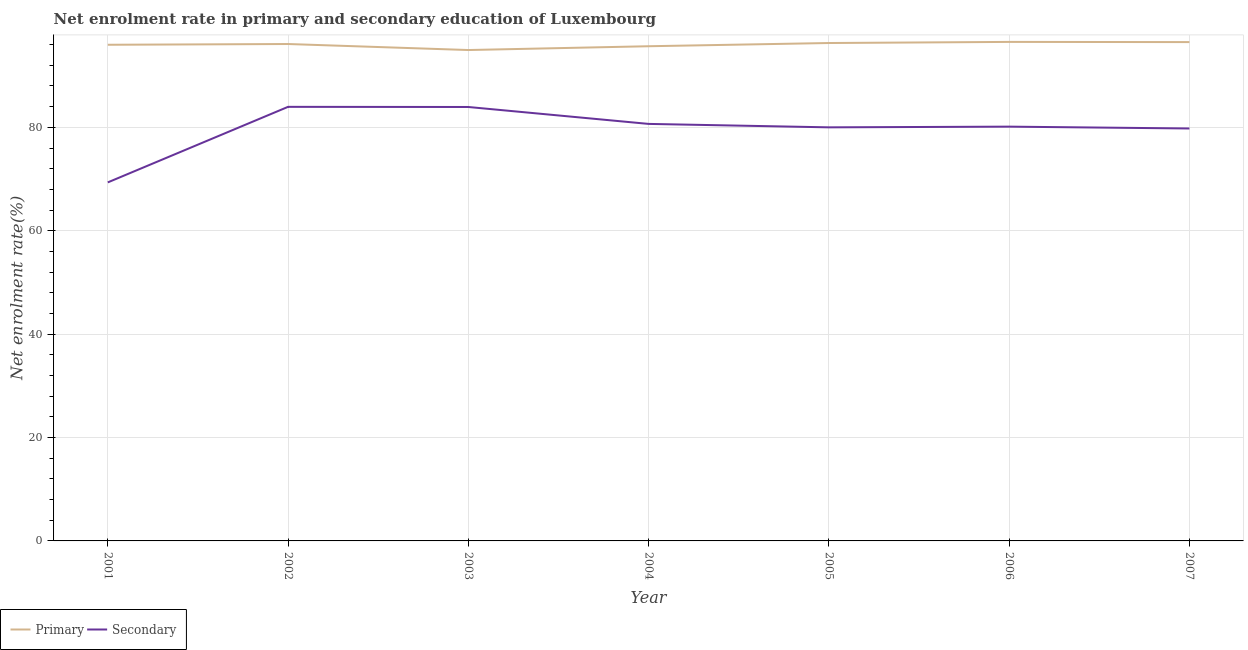Is the number of lines equal to the number of legend labels?
Your response must be concise. Yes. What is the enrollment rate in secondary education in 2006?
Offer a terse response. 80.13. Across all years, what is the maximum enrollment rate in secondary education?
Ensure brevity in your answer.  83.96. Across all years, what is the minimum enrollment rate in primary education?
Give a very brief answer. 94.95. In which year was the enrollment rate in secondary education minimum?
Offer a very short reply. 2001. What is the total enrollment rate in secondary education in the graph?
Offer a very short reply. 557.82. What is the difference between the enrollment rate in secondary education in 2001 and that in 2007?
Your response must be concise. -10.43. What is the difference between the enrollment rate in secondary education in 2006 and the enrollment rate in primary education in 2002?
Give a very brief answer. -15.98. What is the average enrollment rate in primary education per year?
Your response must be concise. 96.01. In the year 2004, what is the difference between the enrollment rate in secondary education and enrollment rate in primary education?
Offer a terse response. -15.02. In how many years, is the enrollment rate in primary education greater than 36 %?
Make the answer very short. 7. What is the ratio of the enrollment rate in secondary education in 2003 to that in 2005?
Make the answer very short. 1.05. Is the difference between the enrollment rate in secondary education in 2001 and 2007 greater than the difference between the enrollment rate in primary education in 2001 and 2007?
Keep it short and to the point. No. What is the difference between the highest and the second highest enrollment rate in secondary education?
Provide a succinct answer. 0.03. What is the difference between the highest and the lowest enrollment rate in primary education?
Provide a succinct answer. 1.57. Does the enrollment rate in primary education monotonically increase over the years?
Your response must be concise. No. How many lines are there?
Make the answer very short. 2. How many years are there in the graph?
Ensure brevity in your answer.  7. Are the values on the major ticks of Y-axis written in scientific E-notation?
Offer a terse response. No. Where does the legend appear in the graph?
Provide a short and direct response. Bottom left. How many legend labels are there?
Make the answer very short. 2. How are the legend labels stacked?
Offer a terse response. Horizontal. What is the title of the graph?
Ensure brevity in your answer.  Net enrolment rate in primary and secondary education of Luxembourg. What is the label or title of the Y-axis?
Offer a terse response. Net enrolment rate(%). What is the Net enrolment rate(%) of Primary in 2001?
Provide a short and direct response. 95.97. What is the Net enrolment rate(%) of Secondary in 2001?
Offer a very short reply. 69.35. What is the Net enrolment rate(%) in Primary in 2002?
Give a very brief answer. 96.12. What is the Net enrolment rate(%) in Secondary in 2002?
Keep it short and to the point. 83.96. What is the Net enrolment rate(%) in Primary in 2003?
Provide a succinct answer. 94.95. What is the Net enrolment rate(%) of Secondary in 2003?
Provide a short and direct response. 83.94. What is the Net enrolment rate(%) of Primary in 2004?
Keep it short and to the point. 95.69. What is the Net enrolment rate(%) in Secondary in 2004?
Your answer should be very brief. 80.66. What is the Net enrolment rate(%) in Primary in 2005?
Your answer should be very brief. 96.31. What is the Net enrolment rate(%) in Secondary in 2005?
Ensure brevity in your answer.  80. What is the Net enrolment rate(%) in Primary in 2006?
Provide a short and direct response. 96.53. What is the Net enrolment rate(%) of Secondary in 2006?
Your response must be concise. 80.13. What is the Net enrolment rate(%) of Primary in 2007?
Your response must be concise. 96.49. What is the Net enrolment rate(%) in Secondary in 2007?
Your response must be concise. 79.78. Across all years, what is the maximum Net enrolment rate(%) of Primary?
Provide a short and direct response. 96.53. Across all years, what is the maximum Net enrolment rate(%) of Secondary?
Keep it short and to the point. 83.96. Across all years, what is the minimum Net enrolment rate(%) in Primary?
Provide a succinct answer. 94.95. Across all years, what is the minimum Net enrolment rate(%) in Secondary?
Provide a succinct answer. 69.35. What is the total Net enrolment rate(%) in Primary in the graph?
Keep it short and to the point. 672.06. What is the total Net enrolment rate(%) of Secondary in the graph?
Offer a terse response. 557.82. What is the difference between the Net enrolment rate(%) in Primary in 2001 and that in 2002?
Provide a short and direct response. -0.14. What is the difference between the Net enrolment rate(%) of Secondary in 2001 and that in 2002?
Your response must be concise. -14.61. What is the difference between the Net enrolment rate(%) in Primary in 2001 and that in 2003?
Offer a very short reply. 1.02. What is the difference between the Net enrolment rate(%) of Secondary in 2001 and that in 2003?
Your response must be concise. -14.59. What is the difference between the Net enrolment rate(%) of Primary in 2001 and that in 2004?
Offer a terse response. 0.29. What is the difference between the Net enrolment rate(%) of Secondary in 2001 and that in 2004?
Make the answer very short. -11.31. What is the difference between the Net enrolment rate(%) of Primary in 2001 and that in 2005?
Provide a short and direct response. -0.34. What is the difference between the Net enrolment rate(%) in Secondary in 2001 and that in 2005?
Your answer should be very brief. -10.65. What is the difference between the Net enrolment rate(%) in Primary in 2001 and that in 2006?
Your response must be concise. -0.55. What is the difference between the Net enrolment rate(%) of Secondary in 2001 and that in 2006?
Ensure brevity in your answer.  -10.78. What is the difference between the Net enrolment rate(%) in Primary in 2001 and that in 2007?
Offer a terse response. -0.52. What is the difference between the Net enrolment rate(%) in Secondary in 2001 and that in 2007?
Your answer should be compact. -10.43. What is the difference between the Net enrolment rate(%) of Primary in 2002 and that in 2003?
Provide a succinct answer. 1.16. What is the difference between the Net enrolment rate(%) in Secondary in 2002 and that in 2003?
Provide a succinct answer. 0.03. What is the difference between the Net enrolment rate(%) in Primary in 2002 and that in 2004?
Provide a short and direct response. 0.43. What is the difference between the Net enrolment rate(%) of Secondary in 2002 and that in 2004?
Your answer should be very brief. 3.3. What is the difference between the Net enrolment rate(%) in Primary in 2002 and that in 2005?
Offer a terse response. -0.19. What is the difference between the Net enrolment rate(%) of Secondary in 2002 and that in 2005?
Offer a very short reply. 3.96. What is the difference between the Net enrolment rate(%) of Primary in 2002 and that in 2006?
Your response must be concise. -0.41. What is the difference between the Net enrolment rate(%) of Secondary in 2002 and that in 2006?
Keep it short and to the point. 3.83. What is the difference between the Net enrolment rate(%) of Primary in 2002 and that in 2007?
Give a very brief answer. -0.37. What is the difference between the Net enrolment rate(%) of Secondary in 2002 and that in 2007?
Ensure brevity in your answer.  4.19. What is the difference between the Net enrolment rate(%) in Primary in 2003 and that in 2004?
Provide a succinct answer. -0.73. What is the difference between the Net enrolment rate(%) of Secondary in 2003 and that in 2004?
Offer a terse response. 3.27. What is the difference between the Net enrolment rate(%) of Primary in 2003 and that in 2005?
Your answer should be very brief. -1.36. What is the difference between the Net enrolment rate(%) of Secondary in 2003 and that in 2005?
Ensure brevity in your answer.  3.94. What is the difference between the Net enrolment rate(%) in Primary in 2003 and that in 2006?
Provide a succinct answer. -1.57. What is the difference between the Net enrolment rate(%) in Secondary in 2003 and that in 2006?
Provide a succinct answer. 3.8. What is the difference between the Net enrolment rate(%) of Primary in 2003 and that in 2007?
Offer a very short reply. -1.53. What is the difference between the Net enrolment rate(%) in Secondary in 2003 and that in 2007?
Offer a terse response. 4.16. What is the difference between the Net enrolment rate(%) of Primary in 2004 and that in 2005?
Give a very brief answer. -0.62. What is the difference between the Net enrolment rate(%) of Secondary in 2004 and that in 2005?
Your answer should be compact. 0.67. What is the difference between the Net enrolment rate(%) in Primary in 2004 and that in 2006?
Offer a very short reply. -0.84. What is the difference between the Net enrolment rate(%) of Secondary in 2004 and that in 2006?
Give a very brief answer. 0.53. What is the difference between the Net enrolment rate(%) in Primary in 2004 and that in 2007?
Your answer should be compact. -0.8. What is the difference between the Net enrolment rate(%) in Secondary in 2004 and that in 2007?
Provide a short and direct response. 0.89. What is the difference between the Net enrolment rate(%) in Primary in 2005 and that in 2006?
Ensure brevity in your answer.  -0.22. What is the difference between the Net enrolment rate(%) of Secondary in 2005 and that in 2006?
Make the answer very short. -0.14. What is the difference between the Net enrolment rate(%) of Primary in 2005 and that in 2007?
Provide a succinct answer. -0.18. What is the difference between the Net enrolment rate(%) in Secondary in 2005 and that in 2007?
Give a very brief answer. 0.22. What is the difference between the Net enrolment rate(%) of Primary in 2006 and that in 2007?
Your answer should be very brief. 0.04. What is the difference between the Net enrolment rate(%) in Secondary in 2006 and that in 2007?
Offer a very short reply. 0.36. What is the difference between the Net enrolment rate(%) of Primary in 2001 and the Net enrolment rate(%) of Secondary in 2002?
Give a very brief answer. 12.01. What is the difference between the Net enrolment rate(%) of Primary in 2001 and the Net enrolment rate(%) of Secondary in 2003?
Your response must be concise. 12.04. What is the difference between the Net enrolment rate(%) in Primary in 2001 and the Net enrolment rate(%) in Secondary in 2004?
Provide a succinct answer. 15.31. What is the difference between the Net enrolment rate(%) of Primary in 2001 and the Net enrolment rate(%) of Secondary in 2005?
Offer a very short reply. 15.97. What is the difference between the Net enrolment rate(%) of Primary in 2001 and the Net enrolment rate(%) of Secondary in 2006?
Provide a succinct answer. 15.84. What is the difference between the Net enrolment rate(%) of Primary in 2001 and the Net enrolment rate(%) of Secondary in 2007?
Offer a very short reply. 16.2. What is the difference between the Net enrolment rate(%) of Primary in 2002 and the Net enrolment rate(%) of Secondary in 2003?
Keep it short and to the point. 12.18. What is the difference between the Net enrolment rate(%) of Primary in 2002 and the Net enrolment rate(%) of Secondary in 2004?
Make the answer very short. 15.45. What is the difference between the Net enrolment rate(%) in Primary in 2002 and the Net enrolment rate(%) in Secondary in 2005?
Your answer should be very brief. 16.12. What is the difference between the Net enrolment rate(%) of Primary in 2002 and the Net enrolment rate(%) of Secondary in 2006?
Provide a short and direct response. 15.98. What is the difference between the Net enrolment rate(%) of Primary in 2002 and the Net enrolment rate(%) of Secondary in 2007?
Your response must be concise. 16.34. What is the difference between the Net enrolment rate(%) in Primary in 2003 and the Net enrolment rate(%) in Secondary in 2004?
Your answer should be compact. 14.29. What is the difference between the Net enrolment rate(%) in Primary in 2003 and the Net enrolment rate(%) in Secondary in 2005?
Give a very brief answer. 14.96. What is the difference between the Net enrolment rate(%) in Primary in 2003 and the Net enrolment rate(%) in Secondary in 2006?
Your answer should be very brief. 14.82. What is the difference between the Net enrolment rate(%) in Primary in 2003 and the Net enrolment rate(%) in Secondary in 2007?
Provide a succinct answer. 15.18. What is the difference between the Net enrolment rate(%) in Primary in 2004 and the Net enrolment rate(%) in Secondary in 2005?
Your answer should be compact. 15.69. What is the difference between the Net enrolment rate(%) in Primary in 2004 and the Net enrolment rate(%) in Secondary in 2006?
Make the answer very short. 15.55. What is the difference between the Net enrolment rate(%) in Primary in 2004 and the Net enrolment rate(%) in Secondary in 2007?
Give a very brief answer. 15.91. What is the difference between the Net enrolment rate(%) of Primary in 2005 and the Net enrolment rate(%) of Secondary in 2006?
Offer a very short reply. 16.18. What is the difference between the Net enrolment rate(%) in Primary in 2005 and the Net enrolment rate(%) in Secondary in 2007?
Offer a very short reply. 16.53. What is the difference between the Net enrolment rate(%) in Primary in 2006 and the Net enrolment rate(%) in Secondary in 2007?
Give a very brief answer. 16.75. What is the average Net enrolment rate(%) in Primary per year?
Offer a terse response. 96.01. What is the average Net enrolment rate(%) of Secondary per year?
Provide a short and direct response. 79.69. In the year 2001, what is the difference between the Net enrolment rate(%) of Primary and Net enrolment rate(%) of Secondary?
Keep it short and to the point. 26.62. In the year 2002, what is the difference between the Net enrolment rate(%) of Primary and Net enrolment rate(%) of Secondary?
Provide a short and direct response. 12.15. In the year 2003, what is the difference between the Net enrolment rate(%) of Primary and Net enrolment rate(%) of Secondary?
Keep it short and to the point. 11.02. In the year 2004, what is the difference between the Net enrolment rate(%) of Primary and Net enrolment rate(%) of Secondary?
Offer a very short reply. 15.02. In the year 2005, what is the difference between the Net enrolment rate(%) in Primary and Net enrolment rate(%) in Secondary?
Your answer should be very brief. 16.31. In the year 2006, what is the difference between the Net enrolment rate(%) of Primary and Net enrolment rate(%) of Secondary?
Make the answer very short. 16.39. In the year 2007, what is the difference between the Net enrolment rate(%) of Primary and Net enrolment rate(%) of Secondary?
Ensure brevity in your answer.  16.71. What is the ratio of the Net enrolment rate(%) of Secondary in 2001 to that in 2002?
Offer a terse response. 0.83. What is the ratio of the Net enrolment rate(%) in Primary in 2001 to that in 2003?
Offer a very short reply. 1.01. What is the ratio of the Net enrolment rate(%) of Secondary in 2001 to that in 2003?
Ensure brevity in your answer.  0.83. What is the ratio of the Net enrolment rate(%) of Secondary in 2001 to that in 2004?
Your answer should be compact. 0.86. What is the ratio of the Net enrolment rate(%) in Primary in 2001 to that in 2005?
Offer a very short reply. 1. What is the ratio of the Net enrolment rate(%) in Secondary in 2001 to that in 2005?
Give a very brief answer. 0.87. What is the ratio of the Net enrolment rate(%) of Secondary in 2001 to that in 2006?
Provide a short and direct response. 0.87. What is the ratio of the Net enrolment rate(%) in Secondary in 2001 to that in 2007?
Offer a very short reply. 0.87. What is the ratio of the Net enrolment rate(%) of Primary in 2002 to that in 2003?
Offer a terse response. 1.01. What is the ratio of the Net enrolment rate(%) of Secondary in 2002 to that in 2004?
Ensure brevity in your answer.  1.04. What is the ratio of the Net enrolment rate(%) of Primary in 2002 to that in 2005?
Ensure brevity in your answer.  1. What is the ratio of the Net enrolment rate(%) in Secondary in 2002 to that in 2005?
Provide a short and direct response. 1.05. What is the ratio of the Net enrolment rate(%) of Primary in 2002 to that in 2006?
Ensure brevity in your answer.  1. What is the ratio of the Net enrolment rate(%) in Secondary in 2002 to that in 2006?
Provide a short and direct response. 1.05. What is the ratio of the Net enrolment rate(%) of Secondary in 2002 to that in 2007?
Offer a very short reply. 1.05. What is the ratio of the Net enrolment rate(%) in Secondary in 2003 to that in 2004?
Make the answer very short. 1.04. What is the ratio of the Net enrolment rate(%) of Primary in 2003 to that in 2005?
Make the answer very short. 0.99. What is the ratio of the Net enrolment rate(%) in Secondary in 2003 to that in 2005?
Keep it short and to the point. 1.05. What is the ratio of the Net enrolment rate(%) in Primary in 2003 to that in 2006?
Offer a very short reply. 0.98. What is the ratio of the Net enrolment rate(%) in Secondary in 2003 to that in 2006?
Your answer should be compact. 1.05. What is the ratio of the Net enrolment rate(%) in Primary in 2003 to that in 2007?
Your answer should be compact. 0.98. What is the ratio of the Net enrolment rate(%) in Secondary in 2003 to that in 2007?
Make the answer very short. 1.05. What is the ratio of the Net enrolment rate(%) in Primary in 2004 to that in 2005?
Make the answer very short. 0.99. What is the ratio of the Net enrolment rate(%) of Secondary in 2004 to that in 2005?
Your response must be concise. 1.01. What is the ratio of the Net enrolment rate(%) in Secondary in 2004 to that in 2006?
Provide a succinct answer. 1.01. What is the ratio of the Net enrolment rate(%) in Secondary in 2004 to that in 2007?
Give a very brief answer. 1.01. What is the ratio of the Net enrolment rate(%) of Primary in 2005 to that in 2006?
Provide a short and direct response. 1. What is the ratio of the Net enrolment rate(%) in Primary in 2006 to that in 2007?
Give a very brief answer. 1. What is the ratio of the Net enrolment rate(%) of Secondary in 2006 to that in 2007?
Your answer should be compact. 1. What is the difference between the highest and the second highest Net enrolment rate(%) of Primary?
Offer a terse response. 0.04. What is the difference between the highest and the second highest Net enrolment rate(%) of Secondary?
Keep it short and to the point. 0.03. What is the difference between the highest and the lowest Net enrolment rate(%) in Primary?
Provide a short and direct response. 1.57. What is the difference between the highest and the lowest Net enrolment rate(%) of Secondary?
Provide a short and direct response. 14.61. 